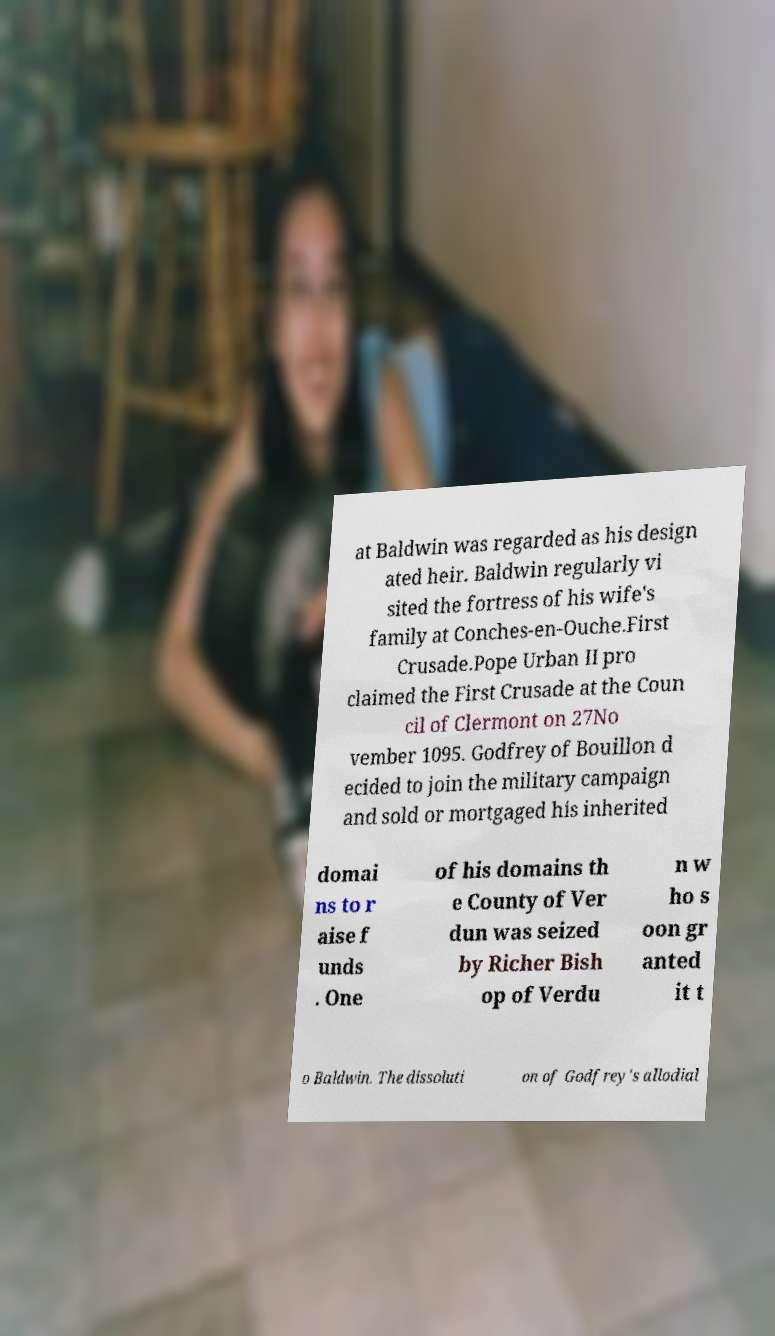Please identify and transcribe the text found in this image. at Baldwin was regarded as his design ated heir. Baldwin regularly vi sited the fortress of his wife's family at Conches-en-Ouche.First Crusade.Pope Urban II pro claimed the First Crusade at the Coun cil of Clermont on 27No vember 1095. Godfrey of Bouillon d ecided to join the military campaign and sold or mortgaged his inherited domai ns to r aise f unds . One of his domains th e County of Ver dun was seized by Richer Bish op of Verdu n w ho s oon gr anted it t o Baldwin. The dissoluti on of Godfrey's allodial 